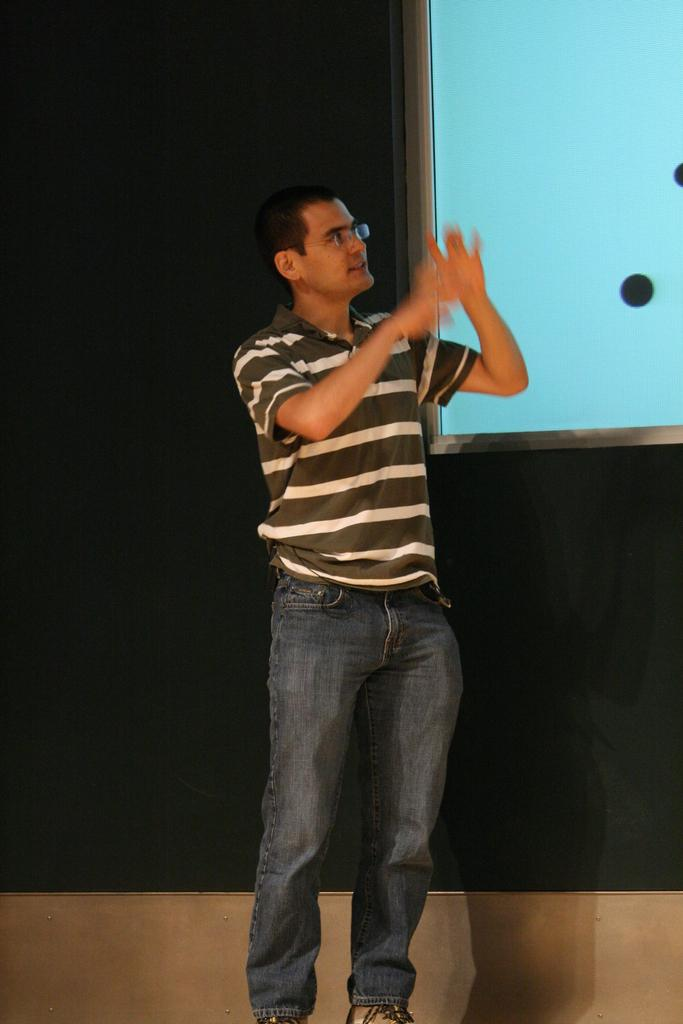Who is the main subject in the image? There is a man in the middle of the image. What is the man wearing? The man is wearing a t-shirt. What can be seen on the right side of the image? There appears to be a projector screen on the right side of the image. What type of plastic is being used to create the grain in the songs in the image? There is no plastic, grain, or songs present in the image. 